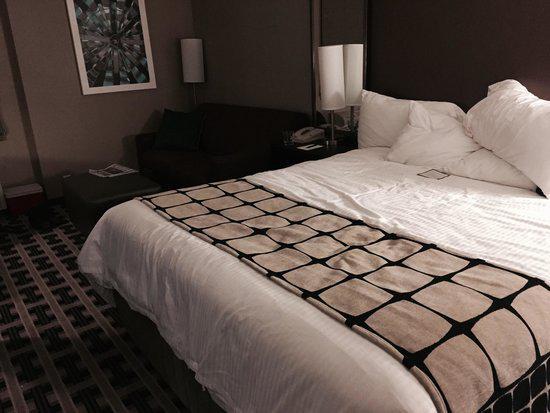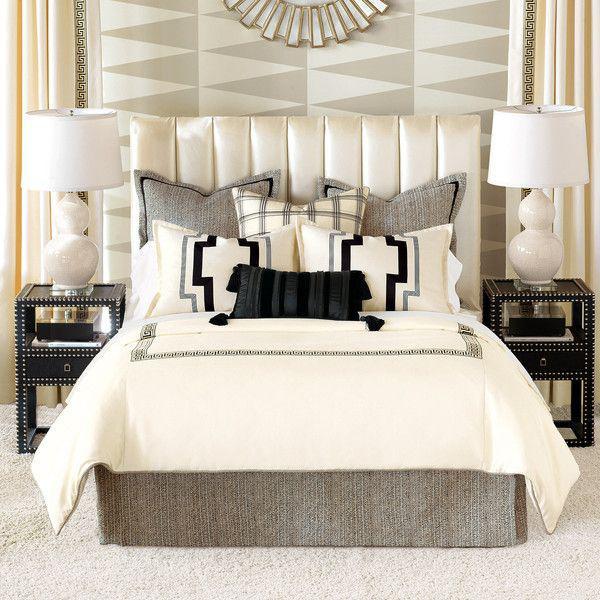The first image is the image on the left, the second image is the image on the right. Analyze the images presented: Is the assertion "There are exactly two table lamps in the image on the left." valid? Answer yes or no. No. 